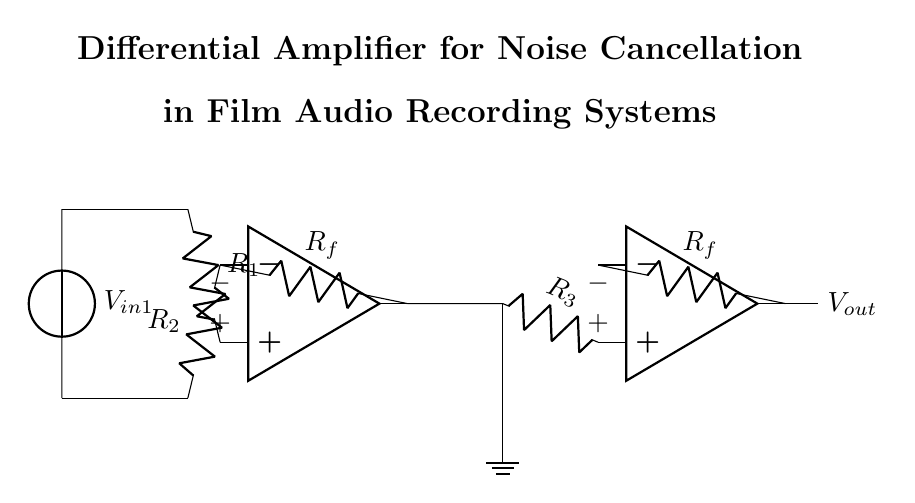What are the two main components in this circuit? The two main components are operational amplifiers, indicated by their symbols in the diagram. These amplifiers process the input signals to achieve the desired noise cancellation effect.
Answer: operational amplifiers What is the purpose of the resistors labeled R1 and R2? Resistors R1 and R2 serve as inputs to the first operational amplifier, setting the gain and influencing the input signal's processing. They help balance the signals to ensure accurate noise cancellation.
Answer: set the gain What is connected to the output of the second operational amplifier? The output of the second operational amplifier is connected to the output node of the circuit, which then delivers the processed voltage signal to be used for audio recording.
Answer: output node How many feedback resistors are present in this circuit? The circuit includes two feedback resistors connected to each operational amplifier, providing negative feedback to stabilize and control the gain of each amplifier.
Answer: two Why are there two operational amplifiers in this circuit? Two operational amplifiers are used to create a differential amplifier configuration, which allows for the cancellation of common noise signals from the input, thereby improving audio quality during recording.
Answer: noise cancellation What is the designation of the input voltage sources in the circuit? The input voltage sources are labeled as V_in1, representing the voltage signals being processed by the differential amplifier to remove noise.
Answer: V_in1 What effect does a differential amplifier have on the signals? A differential amplifier amplifies the difference between two input signals while rejecting any signals that are common to both, effectively reducing noise in the output.
Answer: amplifies differences 